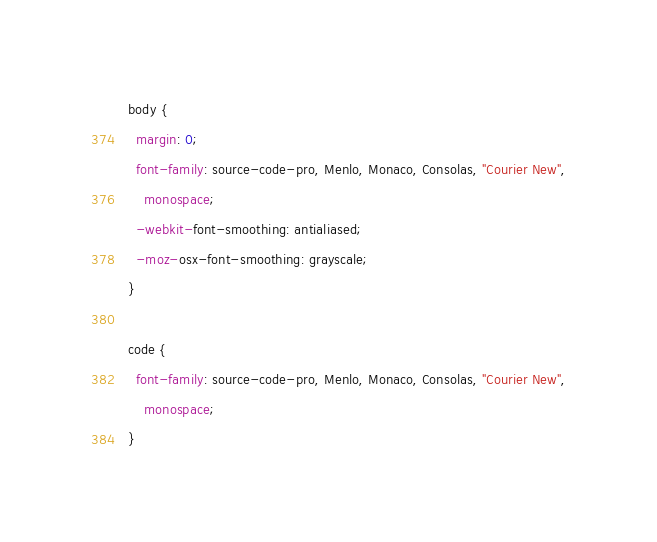Convert code to text. <code><loc_0><loc_0><loc_500><loc_500><_CSS_>body {
  margin: 0;
  font-family: source-code-pro, Menlo, Monaco, Consolas, "Courier New",
    monospace;
  -webkit-font-smoothing: antialiased;
  -moz-osx-font-smoothing: grayscale;
}

code {
  font-family: source-code-pro, Menlo, Monaco, Consolas, "Courier New",
    monospace;
}
</code> 